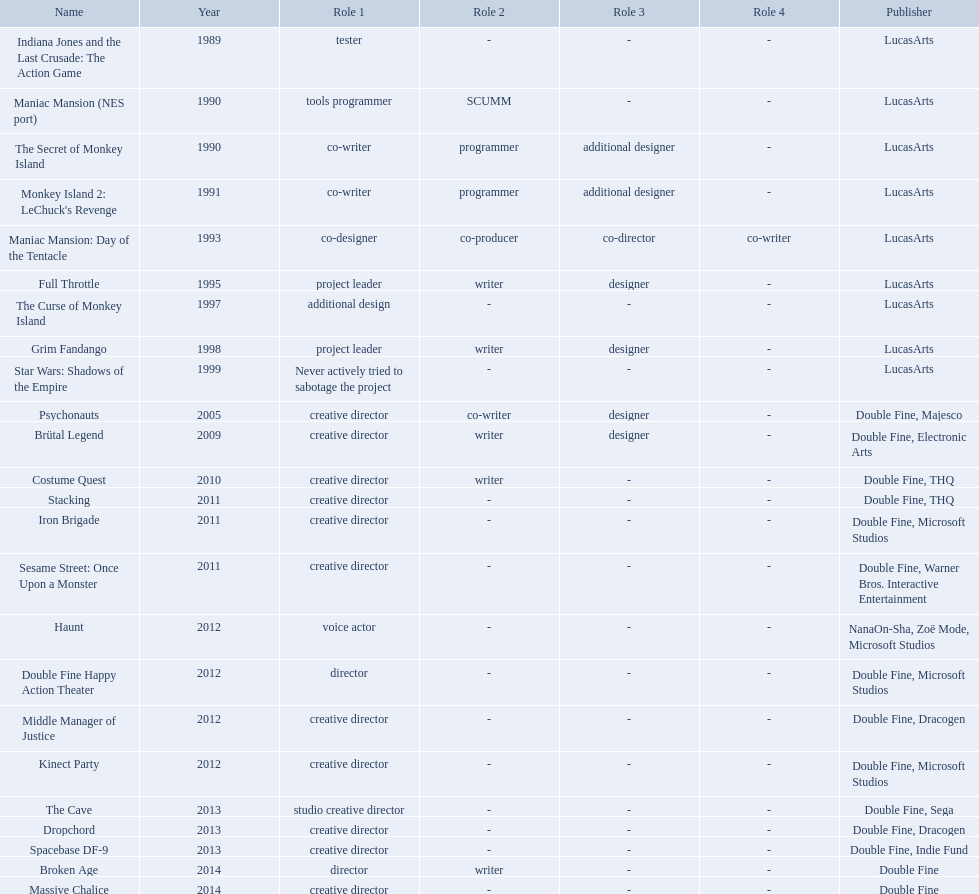What game name has tim schafer been involved with? Indiana Jones and the Last Crusade: The Action Game, Maniac Mansion (NES port), The Secret of Monkey Island, Monkey Island 2: LeChuck's Revenge, Maniac Mansion: Day of the Tentacle, Full Throttle, The Curse of Monkey Island, Grim Fandango, Star Wars: Shadows of the Empire, Psychonauts, Brütal Legend, Costume Quest, Stacking, Iron Brigade, Sesame Street: Once Upon a Monster, Haunt, Double Fine Happy Action Theater, Middle Manager of Justice, Kinect Party, The Cave, Dropchord, Spacebase DF-9, Broken Age, Massive Chalice. Which game has credit with just creative director? Creative director, creative director, creative director, creative director, creative director, creative director, creative director, creative director. Which games have the above and warner bros. interactive entertainment as publisher? Sesame Street: Once Upon a Monster. 